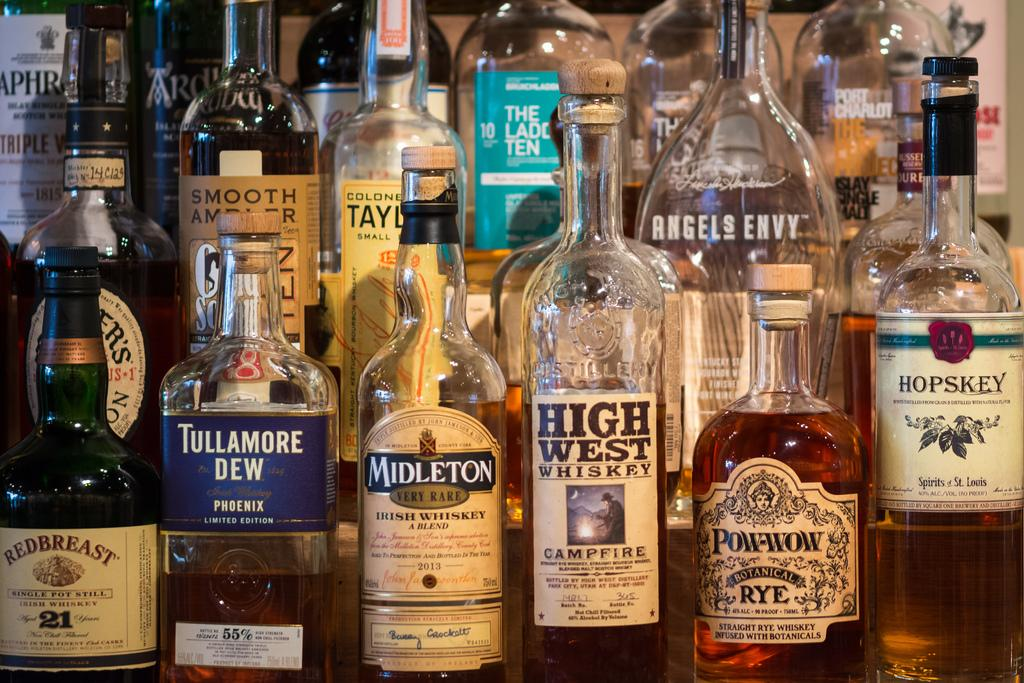Provide a one-sentence caption for the provided image. Many bottles of liquor displayed, including Redbreast Irish Whiskey, Tullamore Dew, Midleton Irish Whiskey, High West Whiskey, and Pow-Wow Botanical Rye. 